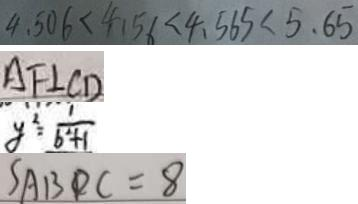Convert formula to latex. <formula><loc_0><loc_0><loc_500><loc_500>4 . 5 0 6 < 4 . 5 6 < 4 . 5 6 5 < 5 . 6 5 
 A F \bot C D 
 y ^ { 2 } = \frac { 1 } { b ^ { 2 } + 1 } 
 S _ { A B D C } = 8</formula> 